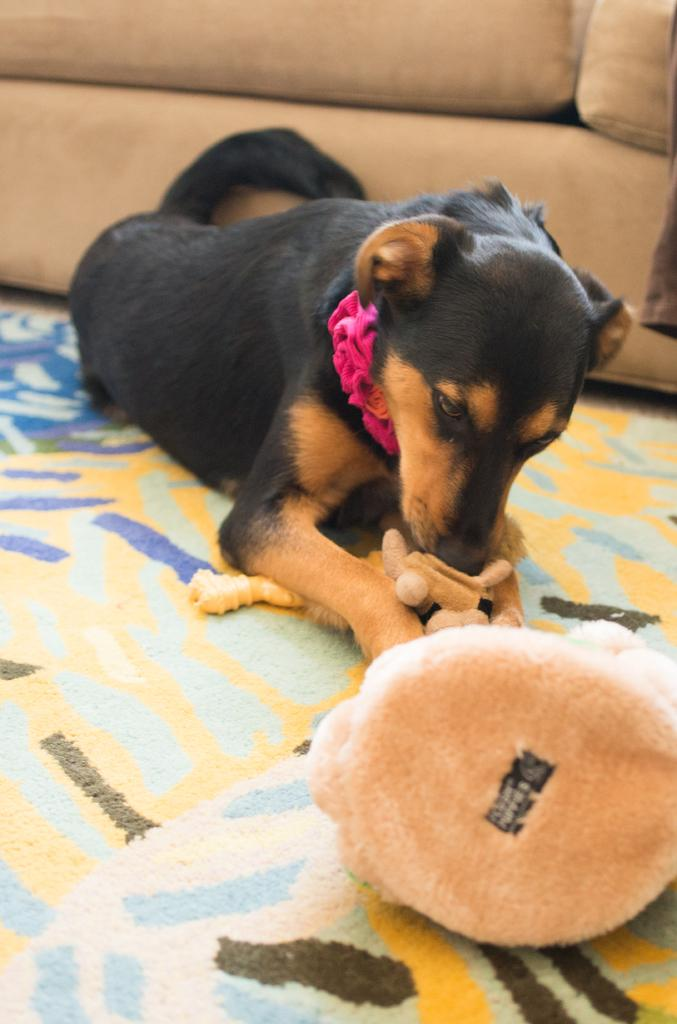What object can be seen in the image that is meant for play or entertainment? There is a toy in the image. What surface is visible in the image that might be used for sitting or lying down? There is a mat in the image. What type of animal is present in the image? There is a black color dog in the image. What type of furniture is visible in the image? There is a sofa in the image. What type of mark can be seen on the toy in the image? There is no mention of a mark on the toy in the image. What type of paste is being used to hold the dog and the toy together in the image? There is no paste or adhesive present in the image; the dog and the toy are separate objects. 